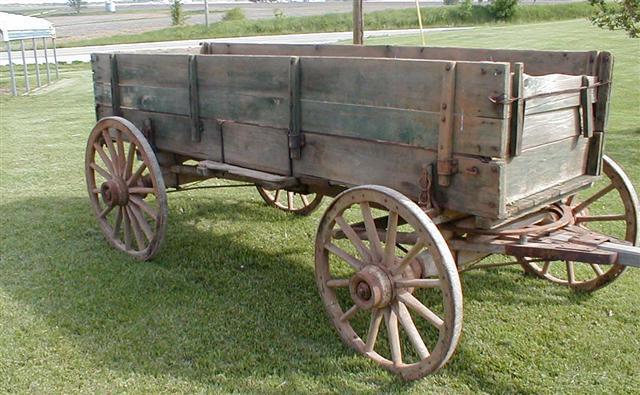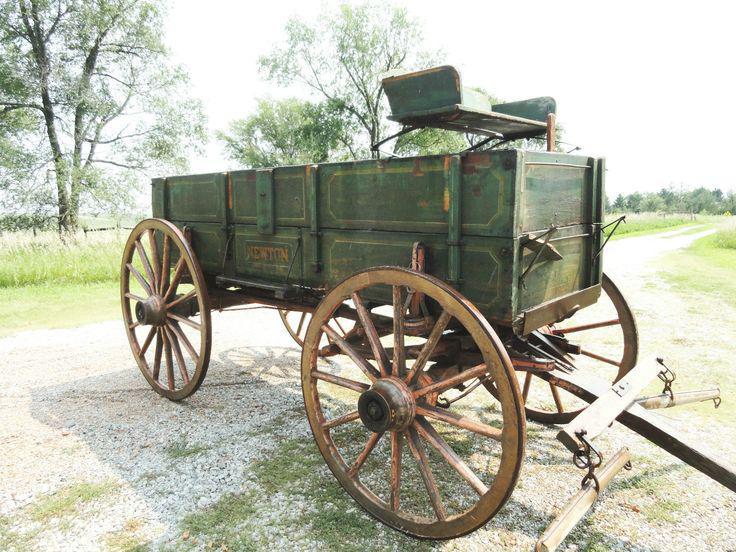The first image is the image on the left, the second image is the image on the right. Evaluate the accuracy of this statement regarding the images: "At least one image shows a two-wheeled cart with no passengers, parked on green grass.". Is it true? Answer yes or no. No. The first image is the image on the left, the second image is the image on the right. Evaluate the accuracy of this statement regarding the images: "There is a two wheel cart in at least one of the images.". Is it true? Answer yes or no. No. 